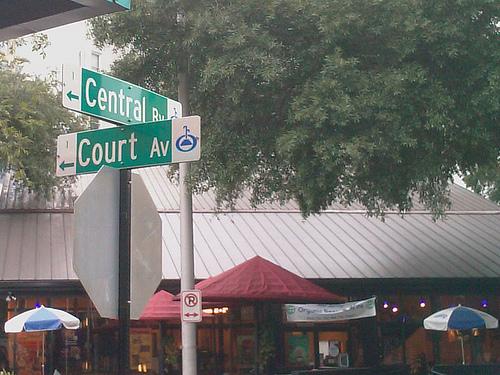How many umbrellas are open?
Give a very brief answer. 4. Is parking allowed?
Be succinct. No. What color are the umbrellas?
Be succinct. Blue and white. Is this a special event?
Quick response, please. No. 